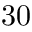Convert formula to latex. <formula><loc_0><loc_0><loc_500><loc_500>3 0</formula> 